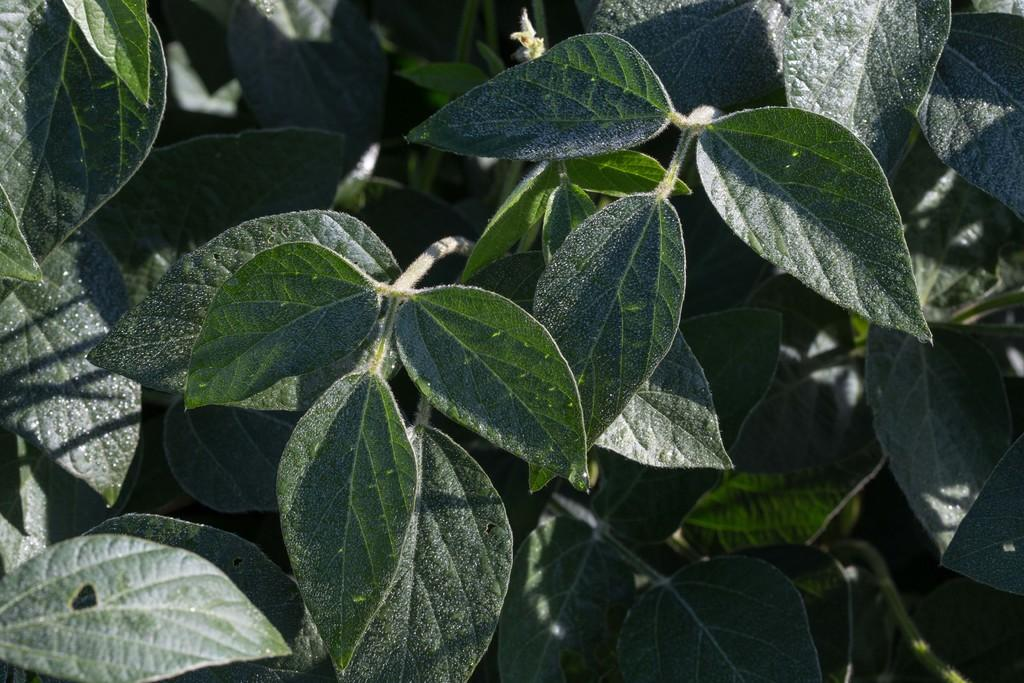What type of vegetation can be seen in the image? There are leaves on plants in the image. What type of government is depicted in the image? There is no government depicted in the image; it features leaves on plants. What type of tin can be seen in the image? There is no tin present in the image; it features leaves on plants. 